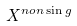<formula> <loc_0><loc_0><loc_500><loc_500>X ^ { n o n \sin g }</formula> 